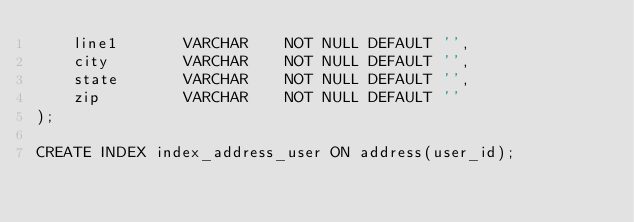Convert code to text. <code><loc_0><loc_0><loc_500><loc_500><_SQL_>    line1       VARCHAR    NOT NULL DEFAULT '',
    city        VARCHAR    NOT NULL DEFAULT '',
    state       VARCHAR    NOT NULL DEFAULT '',
    zip         VARCHAR    NOT NULL DEFAULT ''
);

CREATE INDEX index_address_user ON address(user_id);

</code> 